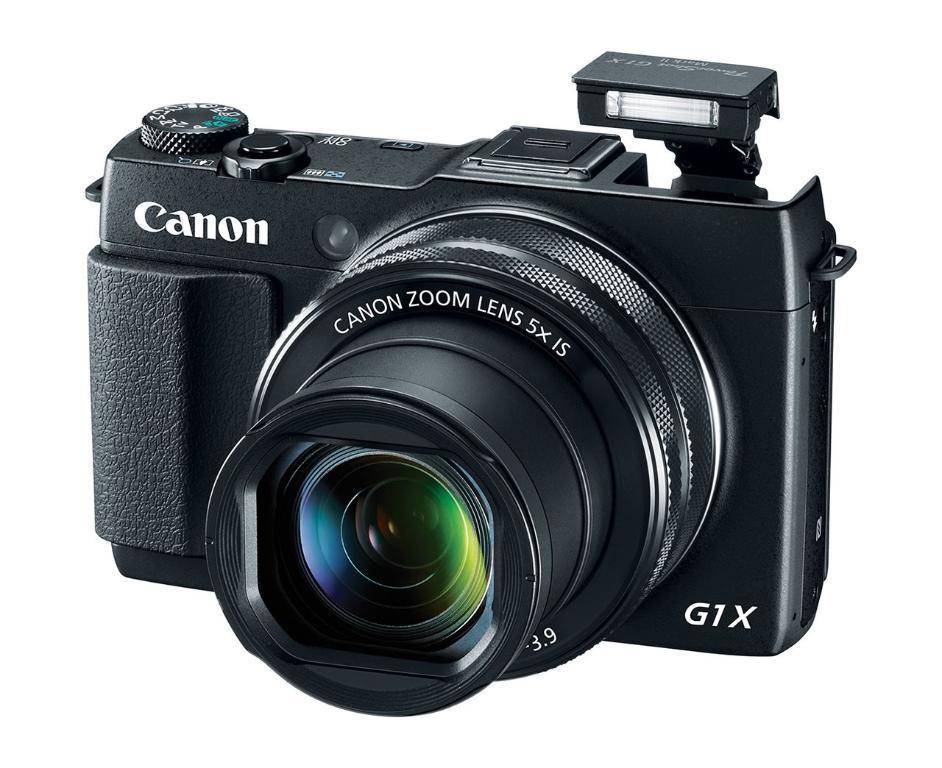Describe this image in one or two sentences. As we can see in the image there is a black color camera. 